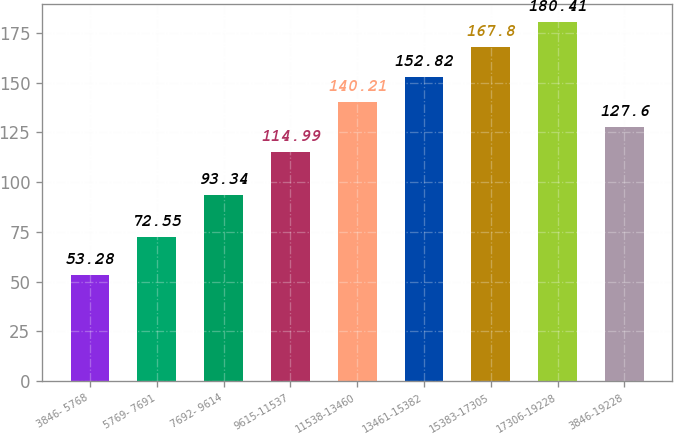Convert chart to OTSL. <chart><loc_0><loc_0><loc_500><loc_500><bar_chart><fcel>3846- 5768<fcel>5769- 7691<fcel>7692- 9614<fcel>9615-11537<fcel>11538-13460<fcel>13461-15382<fcel>15383-17305<fcel>17306-19228<fcel>3846-19228<nl><fcel>53.28<fcel>72.55<fcel>93.34<fcel>114.99<fcel>140.21<fcel>152.82<fcel>167.8<fcel>180.41<fcel>127.6<nl></chart> 